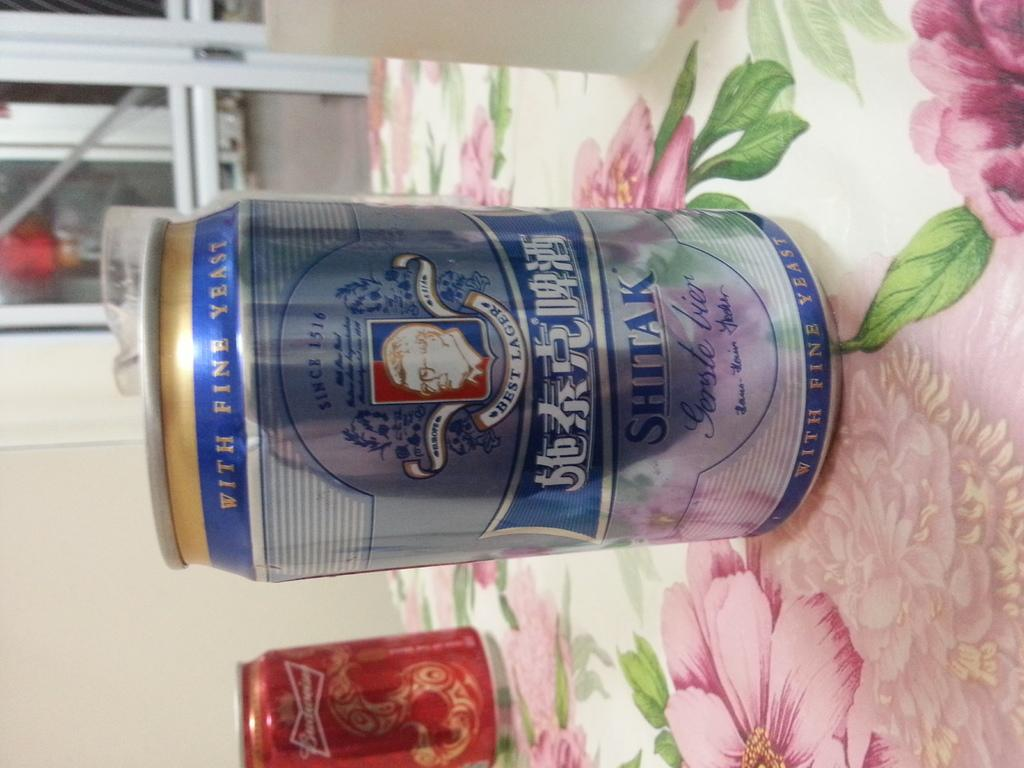<image>
Present a compact description of the photo's key features. A can of Shitak brand beer in the foreground and a can of Budweiser in the background. 